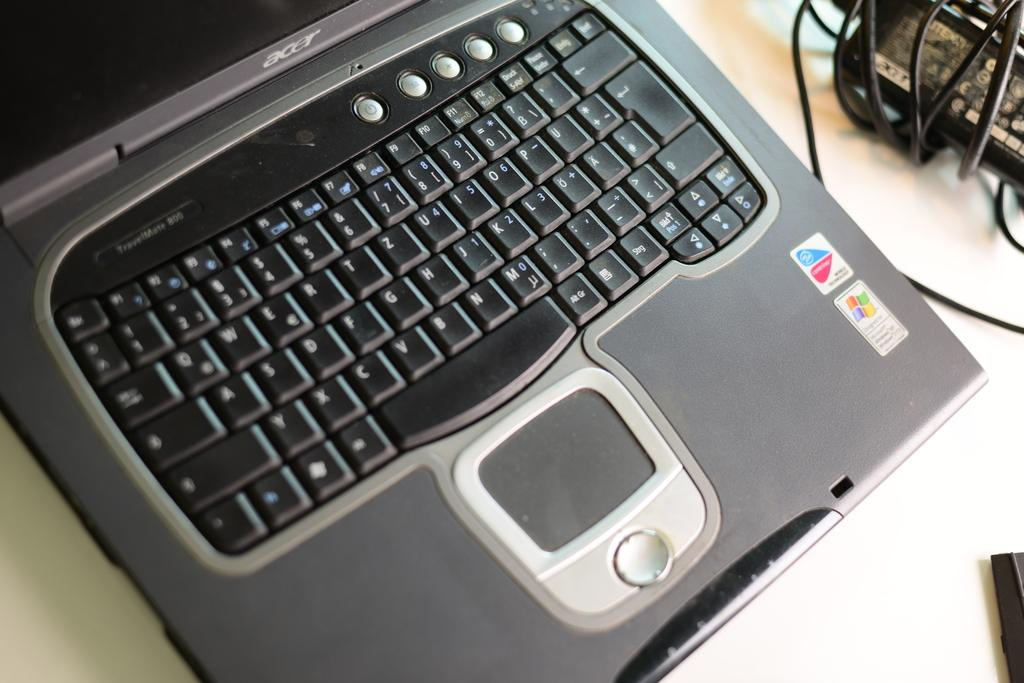<image>
Share a concise interpretation of the image provided. A black and gray acer laptop placed on a white surface. 